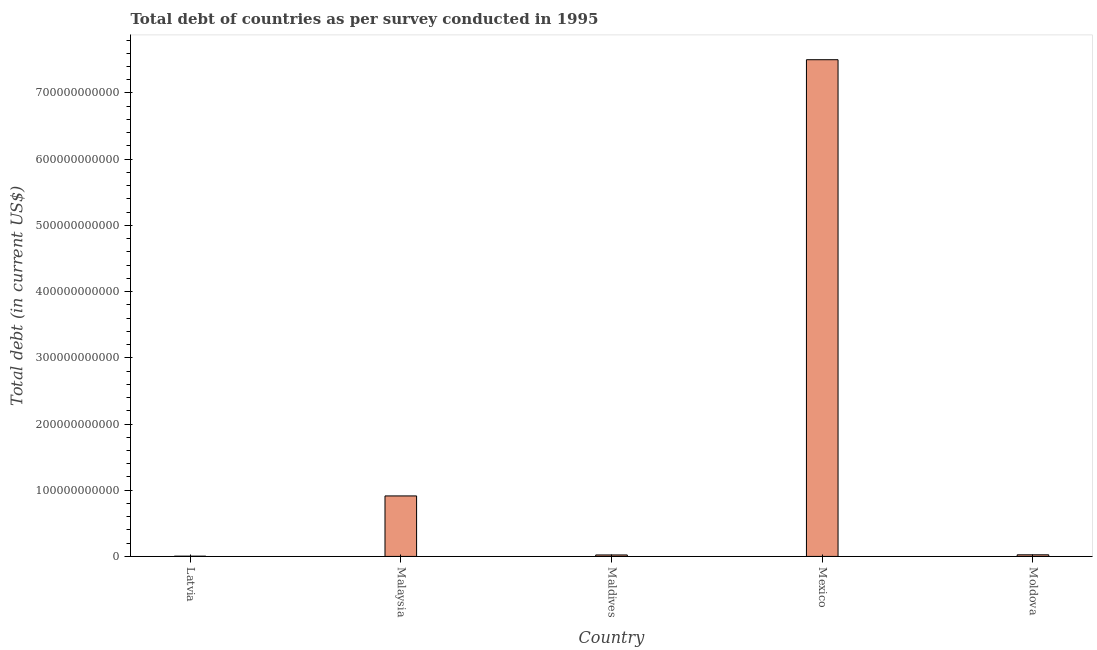Does the graph contain grids?
Ensure brevity in your answer.  No. What is the title of the graph?
Give a very brief answer. Total debt of countries as per survey conducted in 1995. What is the label or title of the X-axis?
Offer a terse response. Country. What is the label or title of the Y-axis?
Your answer should be compact. Total debt (in current US$). What is the total debt in Malaysia?
Offer a terse response. 9.14e+1. Across all countries, what is the maximum total debt?
Ensure brevity in your answer.  7.50e+11. Across all countries, what is the minimum total debt?
Your answer should be very brief. 3.76e+08. In which country was the total debt minimum?
Give a very brief answer. Latvia. What is the sum of the total debt?
Provide a short and direct response. 8.47e+11. What is the difference between the total debt in Mexico and Moldova?
Offer a terse response. 7.48e+11. What is the average total debt per country?
Provide a short and direct response. 1.69e+11. What is the median total debt?
Offer a very short reply. 2.44e+09. What is the ratio of the total debt in Latvia to that in Moldova?
Provide a succinct answer. 0.15. Is the total debt in Latvia less than that in Maldives?
Provide a short and direct response. Yes. Is the difference between the total debt in Malaysia and Mexico greater than the difference between any two countries?
Ensure brevity in your answer.  No. What is the difference between the highest and the second highest total debt?
Ensure brevity in your answer.  6.59e+11. Is the sum of the total debt in Maldives and Mexico greater than the maximum total debt across all countries?
Provide a short and direct response. Yes. What is the difference between the highest and the lowest total debt?
Provide a succinct answer. 7.50e+11. Are all the bars in the graph horizontal?
Give a very brief answer. No. How many countries are there in the graph?
Keep it short and to the point. 5. What is the difference between two consecutive major ticks on the Y-axis?
Provide a succinct answer. 1.00e+11. Are the values on the major ticks of Y-axis written in scientific E-notation?
Provide a succinct answer. No. What is the Total debt (in current US$) in Latvia?
Offer a terse response. 3.76e+08. What is the Total debt (in current US$) in Malaysia?
Keep it short and to the point. 9.14e+1. What is the Total debt (in current US$) in Maldives?
Your answer should be very brief. 2.22e+09. What is the Total debt (in current US$) of Mexico?
Give a very brief answer. 7.50e+11. What is the Total debt (in current US$) of Moldova?
Ensure brevity in your answer.  2.44e+09. What is the difference between the Total debt (in current US$) in Latvia and Malaysia?
Offer a terse response. -9.10e+1. What is the difference between the Total debt (in current US$) in Latvia and Maldives?
Keep it short and to the point. -1.85e+09. What is the difference between the Total debt (in current US$) in Latvia and Mexico?
Your answer should be compact. -7.50e+11. What is the difference between the Total debt (in current US$) in Latvia and Moldova?
Ensure brevity in your answer.  -2.06e+09. What is the difference between the Total debt (in current US$) in Malaysia and Maldives?
Your answer should be very brief. 8.91e+1. What is the difference between the Total debt (in current US$) in Malaysia and Mexico?
Ensure brevity in your answer.  -6.59e+11. What is the difference between the Total debt (in current US$) in Malaysia and Moldova?
Provide a succinct answer. 8.89e+1. What is the difference between the Total debt (in current US$) in Maldives and Mexico?
Your response must be concise. -7.48e+11. What is the difference between the Total debt (in current US$) in Maldives and Moldova?
Provide a short and direct response. -2.15e+08. What is the difference between the Total debt (in current US$) in Mexico and Moldova?
Offer a terse response. 7.48e+11. What is the ratio of the Total debt (in current US$) in Latvia to that in Malaysia?
Keep it short and to the point. 0. What is the ratio of the Total debt (in current US$) in Latvia to that in Maldives?
Provide a short and direct response. 0.17. What is the ratio of the Total debt (in current US$) in Latvia to that in Moldova?
Offer a terse response. 0.15. What is the ratio of the Total debt (in current US$) in Malaysia to that in Maldives?
Provide a short and direct response. 41.09. What is the ratio of the Total debt (in current US$) in Malaysia to that in Mexico?
Your response must be concise. 0.12. What is the ratio of the Total debt (in current US$) in Malaysia to that in Moldova?
Ensure brevity in your answer.  37.47. What is the ratio of the Total debt (in current US$) in Maldives to that in Mexico?
Keep it short and to the point. 0. What is the ratio of the Total debt (in current US$) in Maldives to that in Moldova?
Ensure brevity in your answer.  0.91. What is the ratio of the Total debt (in current US$) in Mexico to that in Moldova?
Offer a terse response. 307.71. 